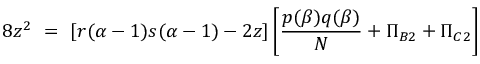<formula> <loc_0><loc_0><loc_500><loc_500>8 z ^ { 2 } = [ r ( \alpha - 1 ) s ( \alpha - 1 ) - 2 z ] \left [ \frac { p ( \beta ) q ( \beta ) } { N } + \Pi _ { B 2 } + \Pi _ { C 2 } \right ]</formula> 